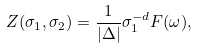<formula> <loc_0><loc_0><loc_500><loc_500>Z ( \sigma _ { 1 } , \sigma _ { 2 } ) = \frac { 1 } { | \Delta | } \sigma _ { 1 } ^ { - d } F ( \omega ) ,</formula> 